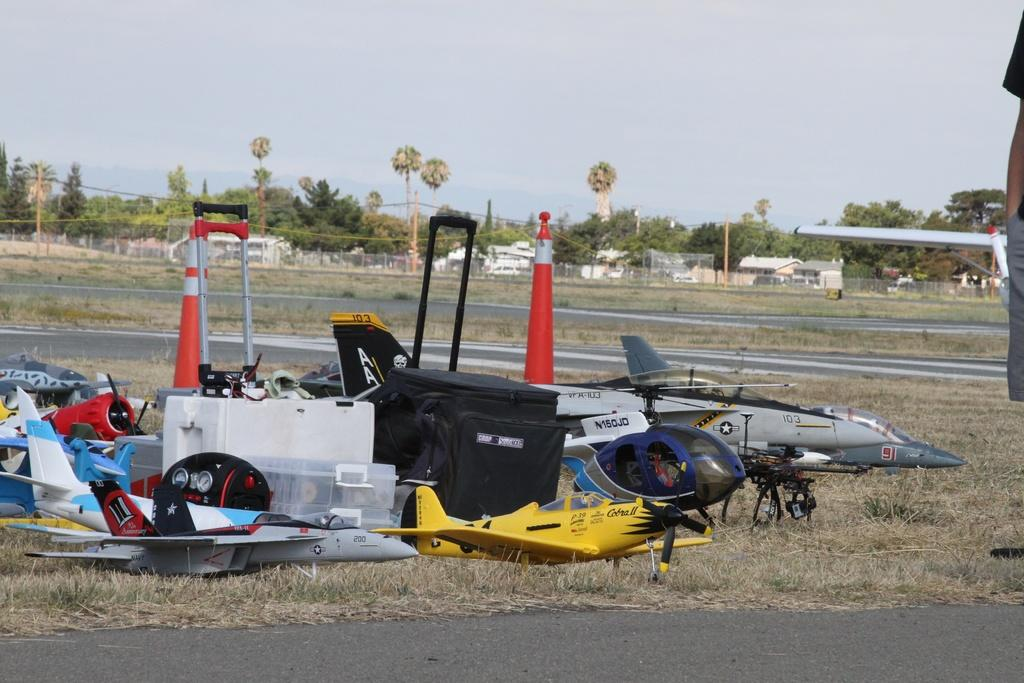<image>
Offer a succinct explanation of the picture presented. An assortment of RC airplanes and a helicopter are on the ground and a jet plane with the numbers 103 and 91 on it. 